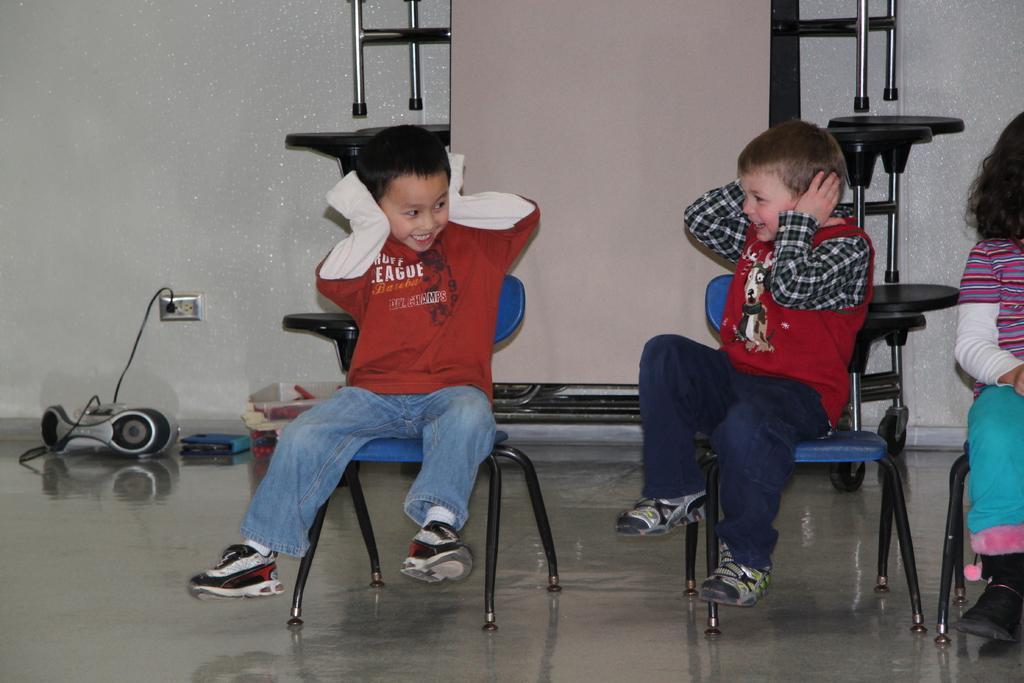Can you describe this image briefly? Here we can see two children sitting on the chairs. They are smiling. This is floor. On the background there is a wall. 